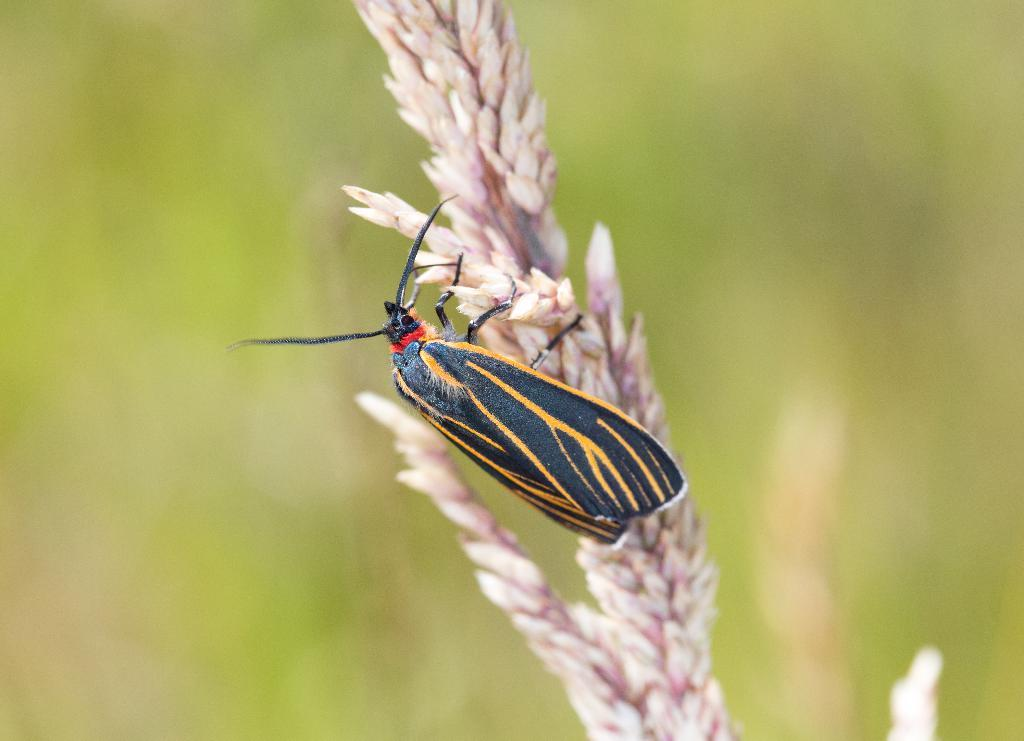What is present on the plant in the image? There is an insect on a plant in the image. Can you describe the background of the image? The background of the image is blurred. What type of spy equipment can be seen in the image? There is no spy equipment present in the image; it features an insect on a plant with a blurred background. 